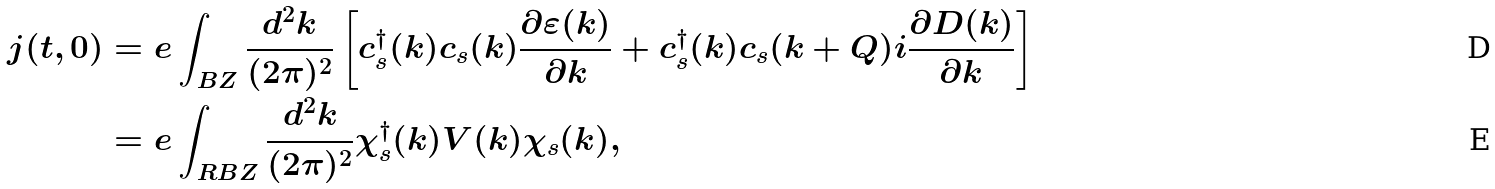<formula> <loc_0><loc_0><loc_500><loc_500>j ( t , 0 ) & = e \int _ { B Z } \frac { d ^ { 2 } k } { ( 2 \pi ) ^ { 2 } } \left [ c _ { s } ^ { \dagger } ( k ) c _ { s } ( k ) \frac { \partial \varepsilon ( k ) } { \partial k } + c _ { s } ^ { \dagger } ( k ) c _ { s } ( k + Q ) i \frac { \partial D ( k ) } { \partial k } \right ] \\ & = e \int _ { R B Z } \frac { d ^ { 2 } k } { ( 2 \pi ) ^ { 2 } } \chi _ { s } ^ { \dagger } ( k ) V ( k ) \chi _ { s } ( k ) ,</formula> 